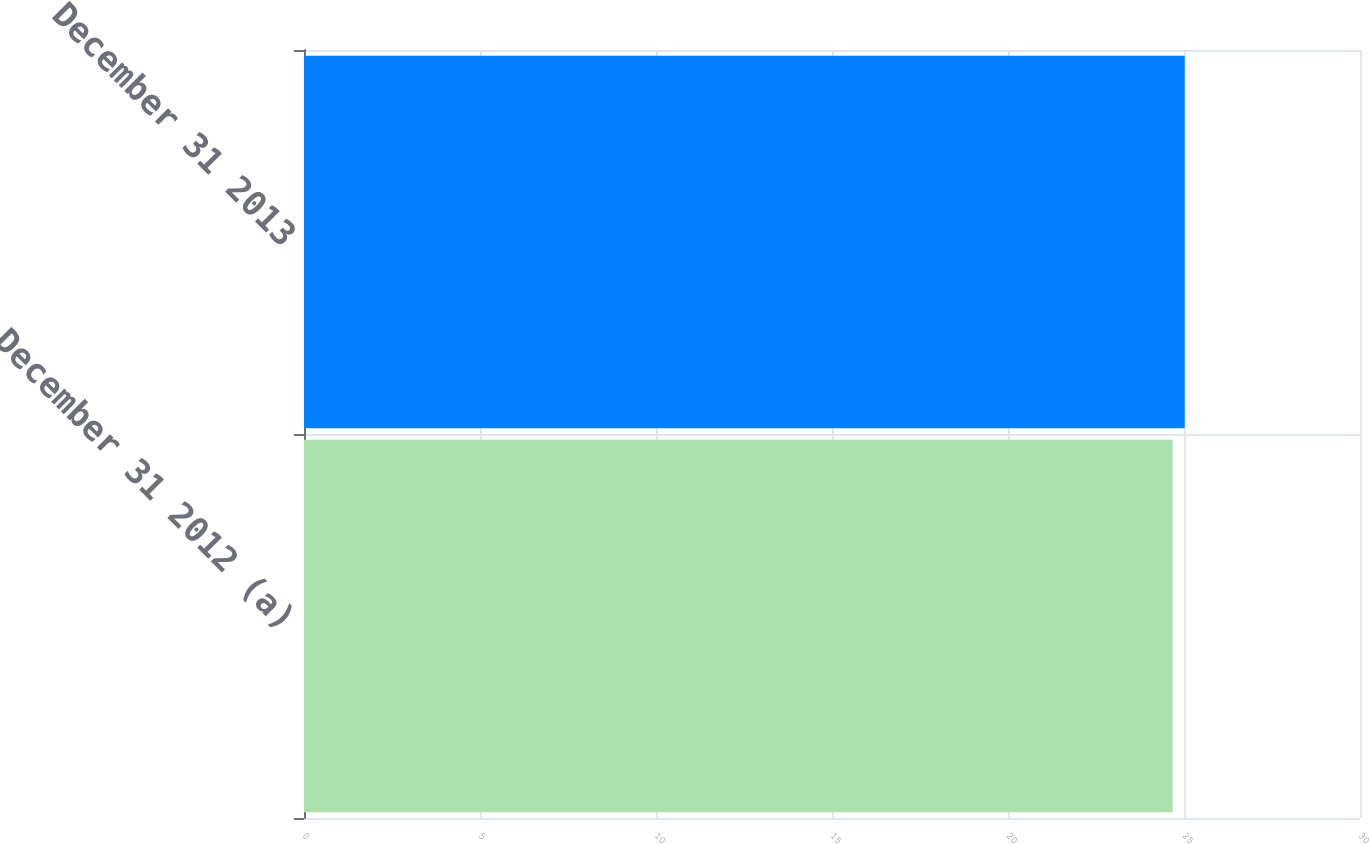Convert chart. <chart><loc_0><loc_0><loc_500><loc_500><bar_chart><fcel>December 31 2012 (a)<fcel>December 31 2013<nl><fcel>24.68<fcel>25.02<nl></chart> 